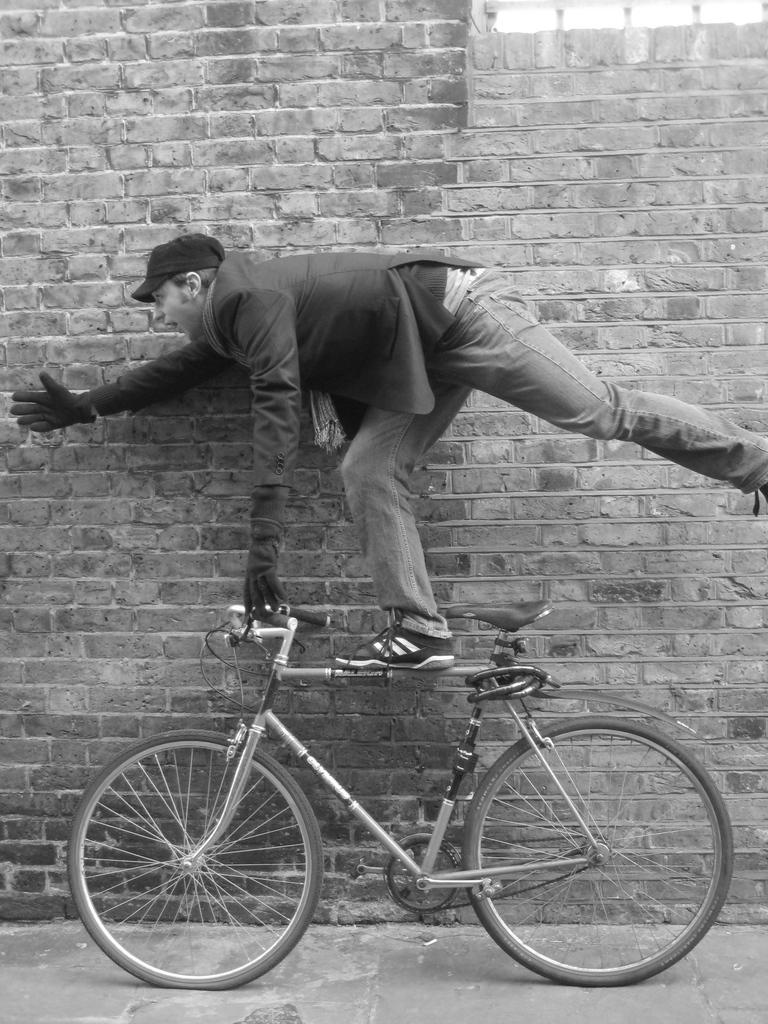What is the main subject of the image? The main subject of the image is a man. What is the man doing in the image? The man is standing on a bicycle. How is the man positioned on the bicycle? The man's one hand is on the handle of the bicycle, and his other hand is spread towards the left side. What is the man wearing in the image? The man is wearing a cap. What can be seen in the background of the image? There is a brick wall in the background of the image. What type of tomatoes can be seen growing on the man's cap in the image? There are no tomatoes present in the image, let alone growing on the man's cap. 